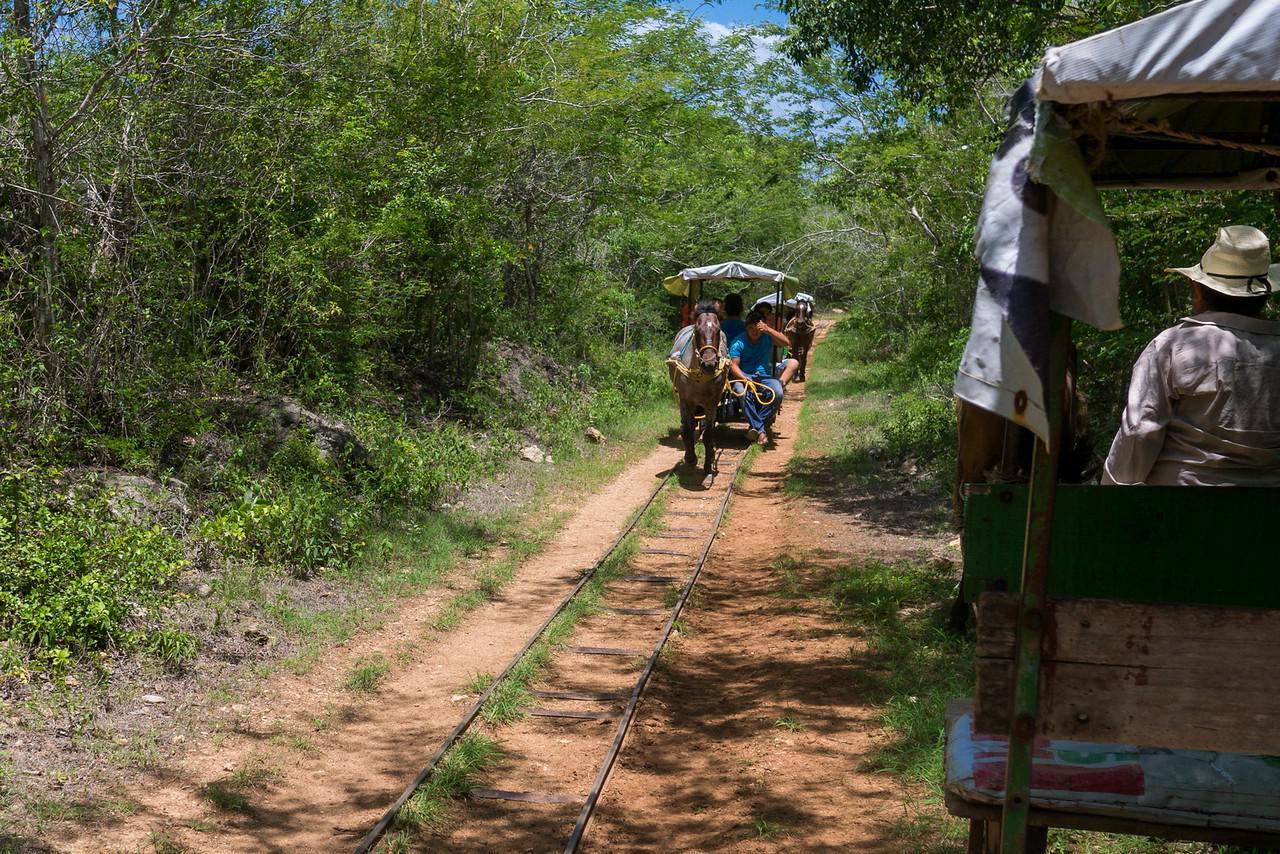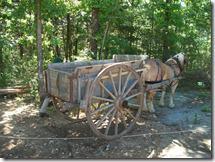The first image is the image on the left, the second image is the image on the right. Evaluate the accuracy of this statement regarding the images: "In one image, carts with fabric canopies are pulled through the woods along a metal track by a single horse.". Is it true? Answer yes or no. Yes. The first image is the image on the left, the second image is the image on the right. For the images shown, is this caption "At least one image shows a cart pulled by two horses." true? Answer yes or no. No. 